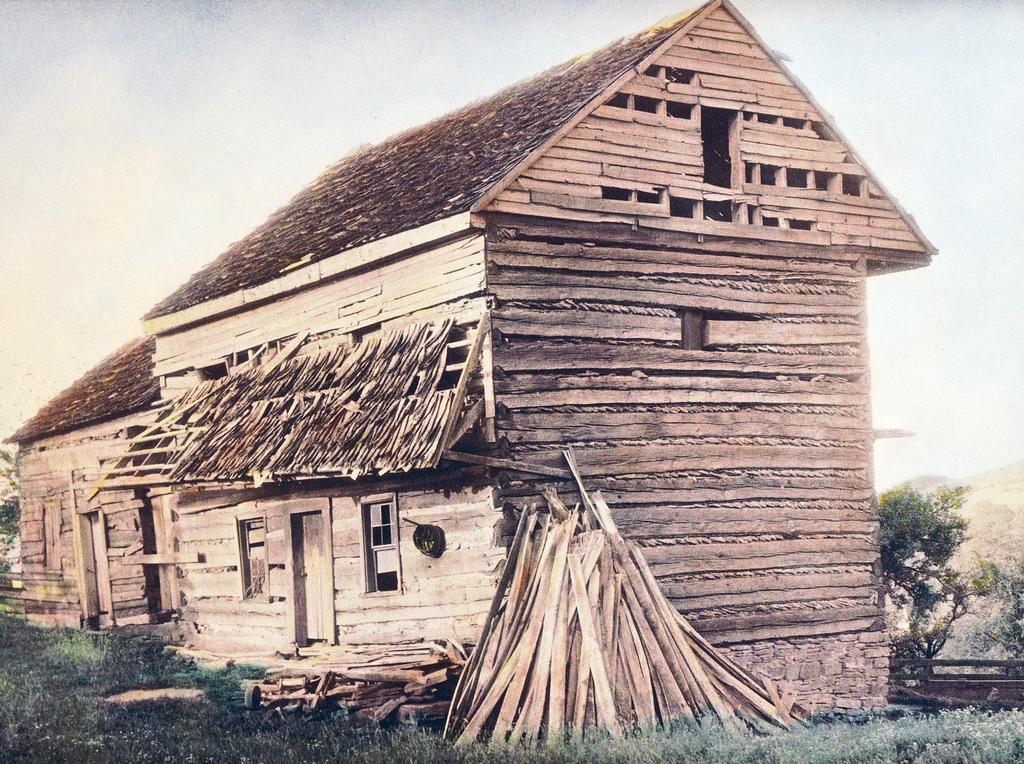What type of structure is in the image? There is a wooden cabin or house in the image. What features can be seen on the cabin or house? The cabin or house has windows. What material is used for the sticks visible in the image? The wooden sticks in the image are made of wood. What type of vegetation is present in the image? There is grass in the image. What other natural elements can be seen in the image? There are trees in the image. What is visible in the background of the image? The sky is visible in the image. How many rays of death can be seen emanating from the cabin in the image? There are no rays of death present in the image; it features a wooden cabin or house with windows, wooden sticks, grass, trees, and a visible sky. 